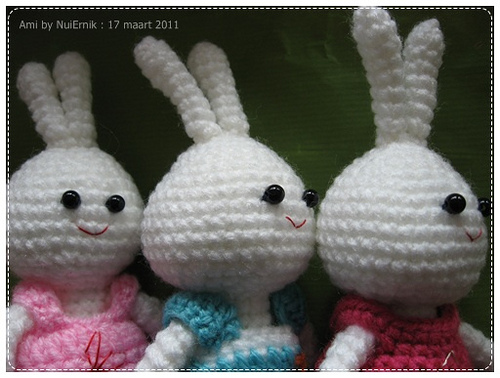<image>
Can you confirm if the doll is behind the dress? Yes. From this viewpoint, the doll is positioned behind the dress, with the dress partially or fully occluding the doll. 